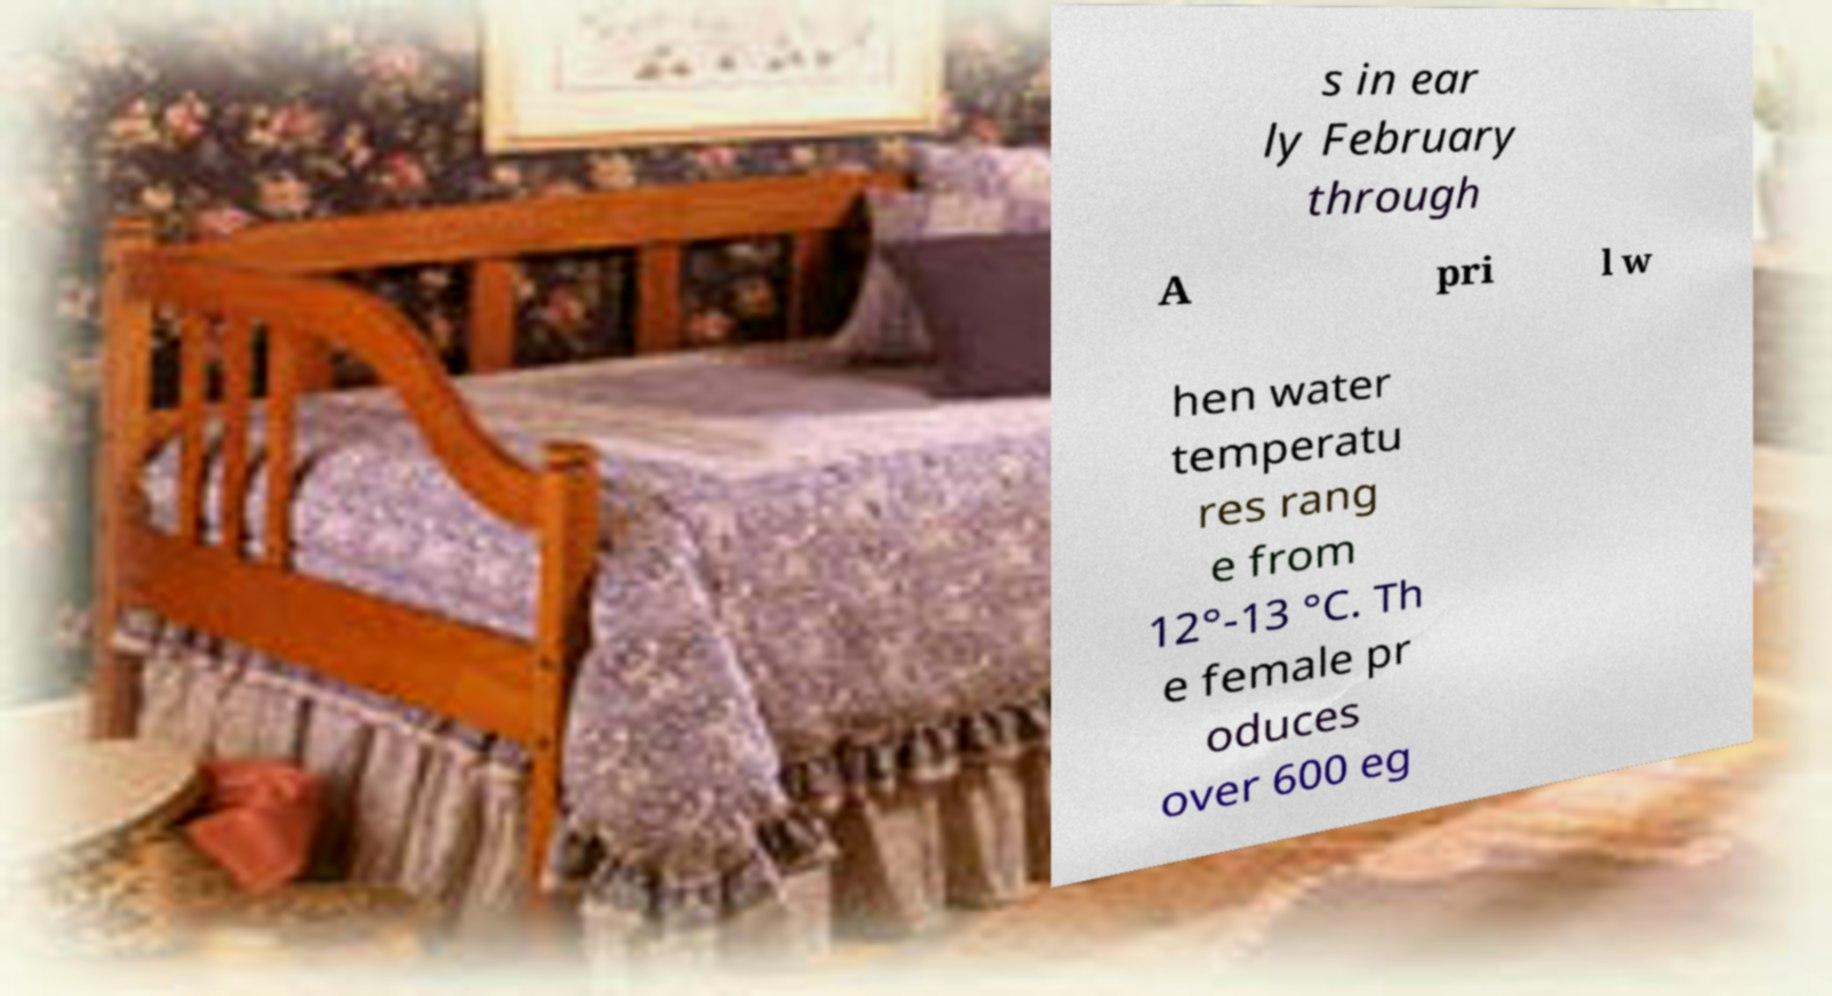Could you assist in decoding the text presented in this image and type it out clearly? s in ear ly February through A pri l w hen water temperatu res rang e from 12°-13 °C. Th e female pr oduces over 600 eg 